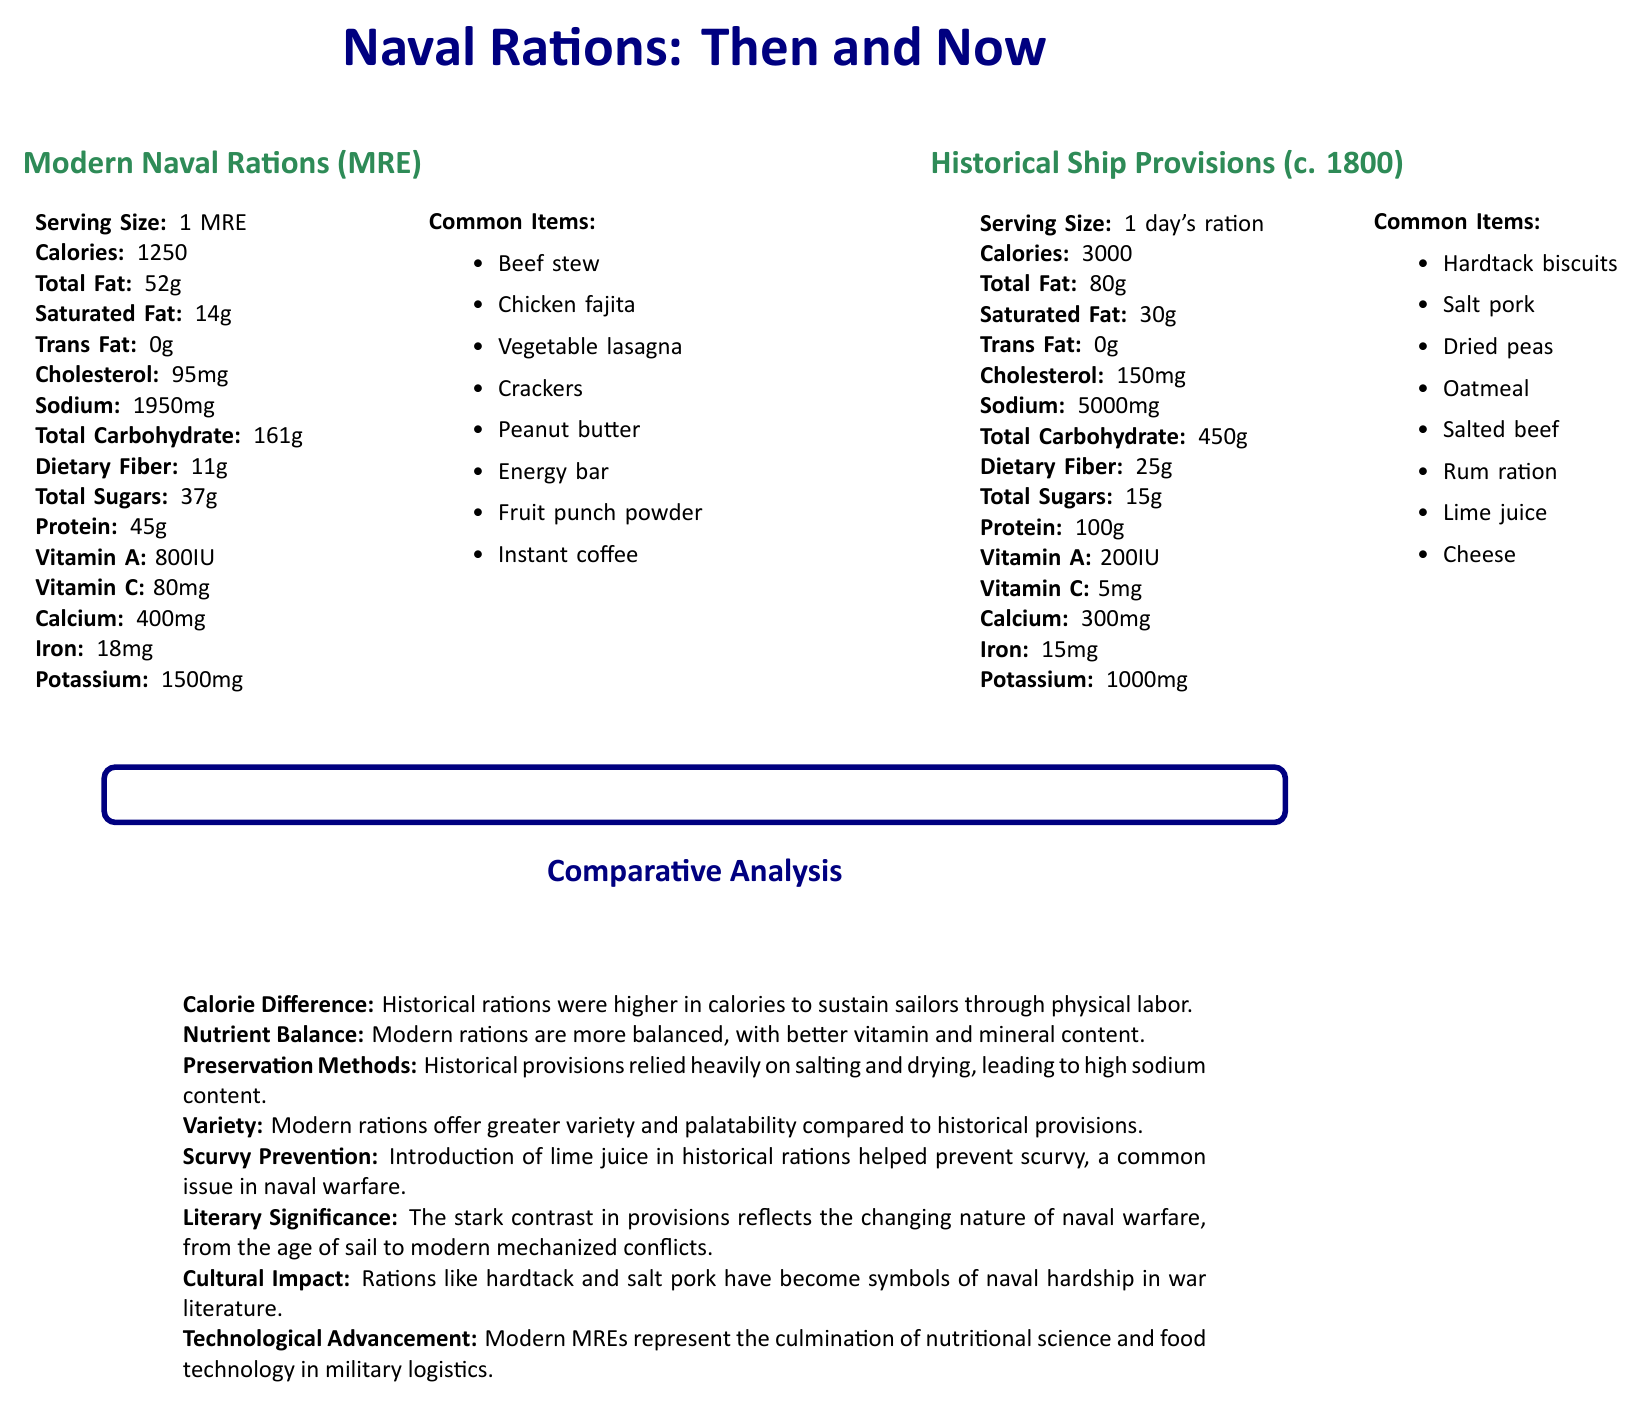what is the serving size of modern naval rations? The document specifies that the serving size for modern naval rations is 1 MRE (Meal, Ready-to-Eat).
Answer: 1 MRE (Meal, Ready-to-Eat) how many calories are in historical ship provisions? The document states that historical ship provisions contain 3000 calories per day's ration (circa 1800).
Answer: 3000 which vitamin is significantly higher in modern naval rations compared to historical ship provisions? Modern naval rations contain 80mg of Vitamin C, while historical ship provisions only contain 5mg.
Answer: Vitamin C why were historical rations so high in sodium content? The document explains that historical provisions relied heavily on salting and drying, which led to high sodium content.
Answer: Preservation methods name two common items found in modern naval rations. The document lists common items in modern naval rations, including Beef stew and Chicken fajita.
Answer: Beef stew, Chicken fajita which ration has higher protein content, modern or historical? A. Modern B. Historical Historical ship provisions contain 100g of protein, whereas modern naval rations contain 45g.
Answer: B what was introduced in historical rations to help prevent scurvy? A. Rum ration B. Lime juice C. Hardtack biscuits D. Salt pork The document states that the introduction of lime juice in historical rations helped prevent scurvy.
Answer: B which modern ration item is designed to be an instant source of energy? A. Beef stew B. Chicken fajita C. Energy bar D. Instant coffee An energy bar is designed to be an instant source of energy, and it’s listed as a common item in modern naval rations.
Answer: C do modern naval rations contain trans fat? The document specifies that modern naval rations have 0g of trans fat.
Answer: No summarize the main idea of the document. The document provides a detailed comparison of modern naval rations (MREs) and historical ship provisions (circa 1800), focusing on their nutritional content, common food items, and various factors such as preservation methods, nutrient balance, and their impact on naval life and literature.
Answer: The document compares the nutrition facts and common items of modern and historical naval rations, highlighting differences in calories, nutrient balance, preservation methods, variety, and their cultural and technological significance. what is the main literary significance of the contrast in naval provisions? The document mentions that the stark contrast in provisions reflects the changing nature of naval warfare, from the age of sail to modern mechanized conflicts.
Answer: Changing nature of naval warfare what is the potassium content of historical ship provisions? The document lists the potassium content of historical ship provisions as 1000mg.
Answer: 1000mg which type of naval ration offers greater variety and palatability? The document states that modern rations offer greater variety and palatability compared to historical provisions.
Answer: Modern naval rations can we determine the daily vitamin needs of sailors from the provided information? The document provides specific vitamin contents in naval rations but does not provide information on the daily vitamin needs of sailors.
Answer: Cannot be determined 